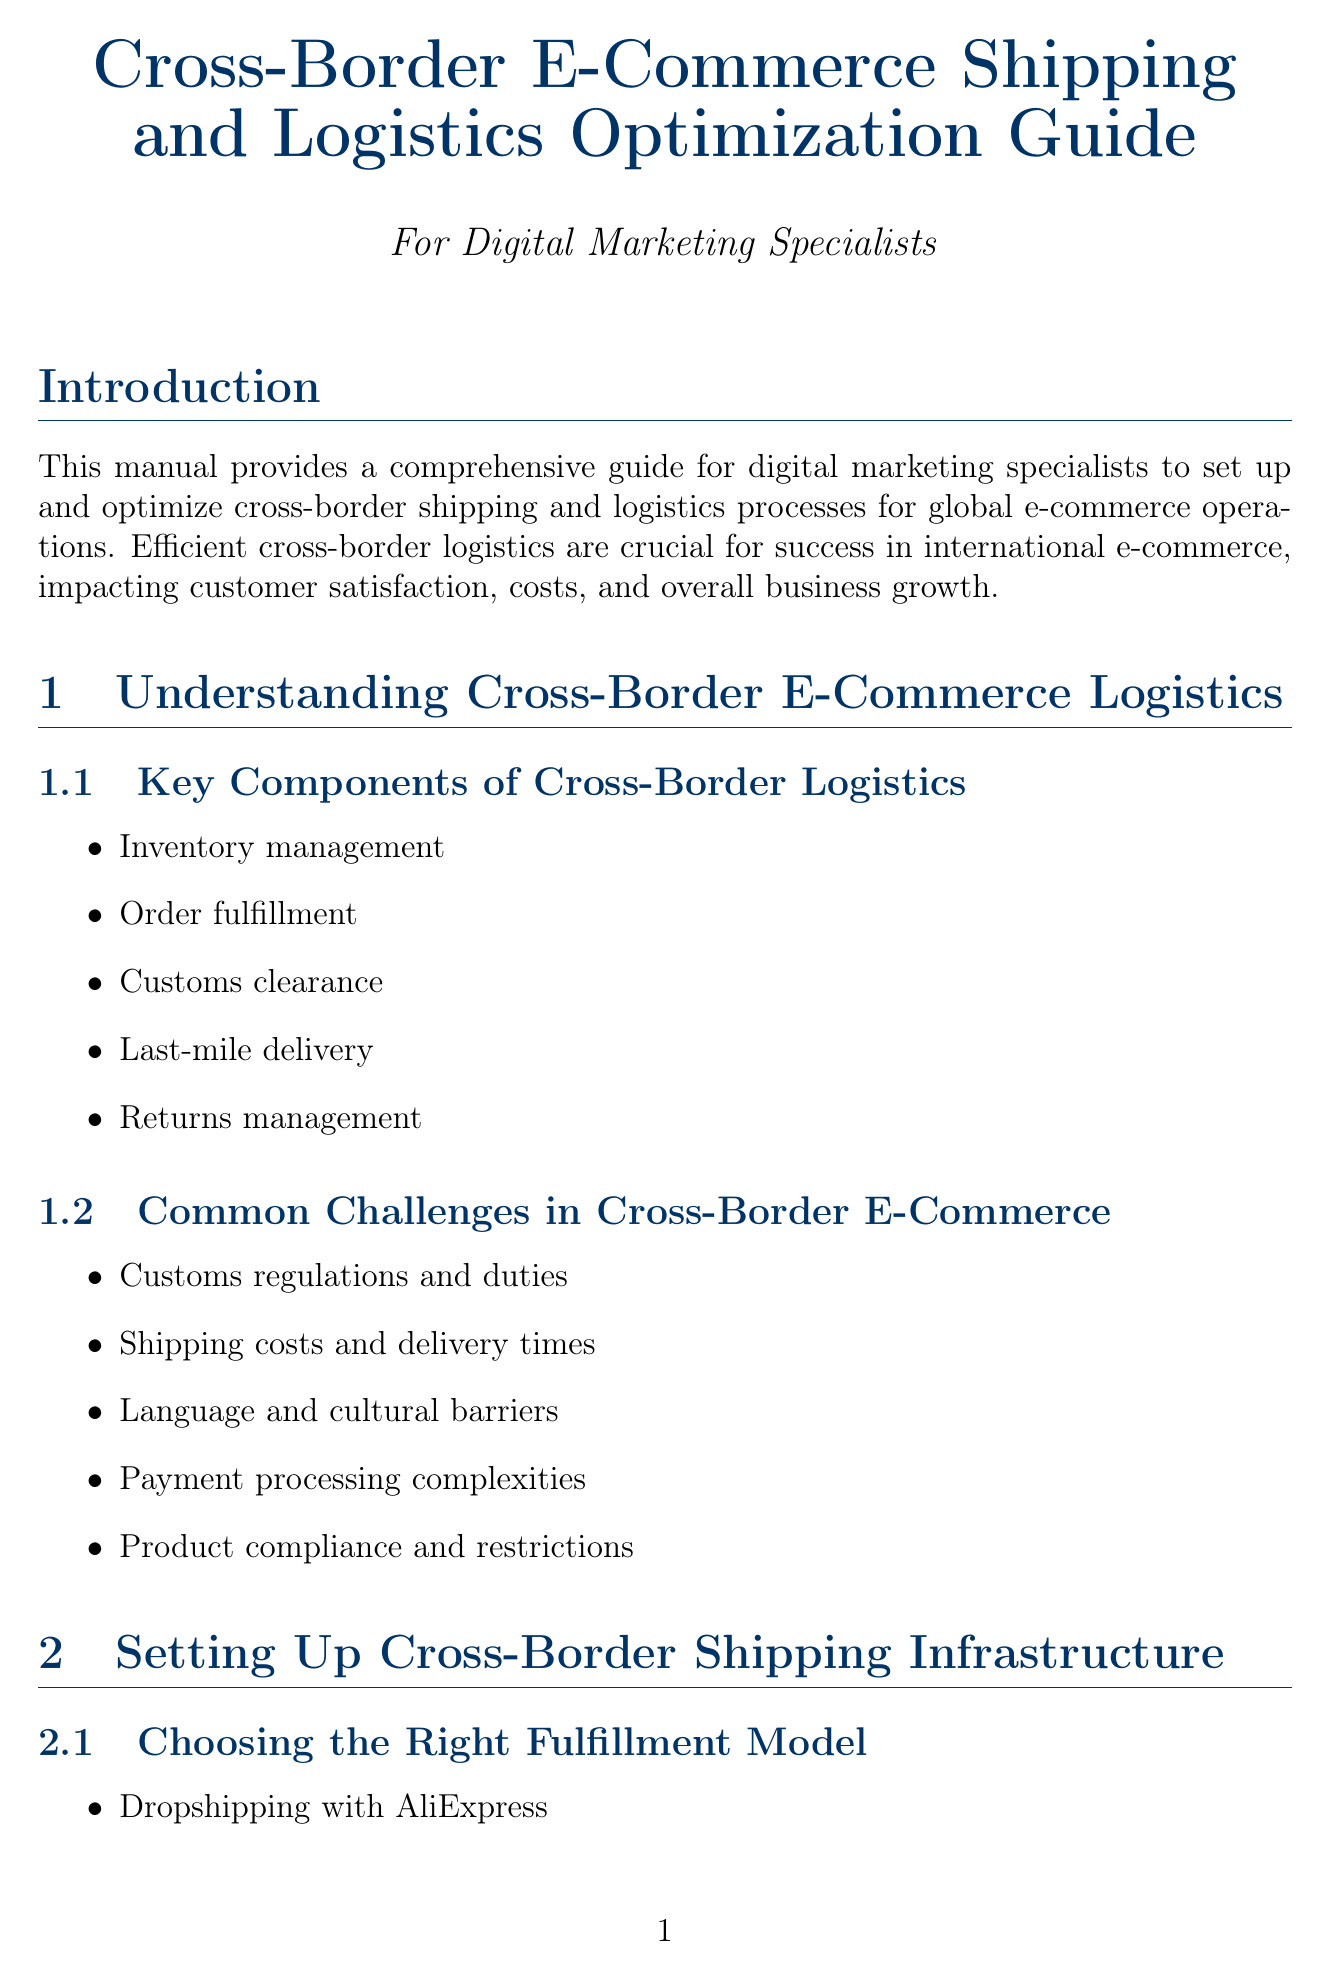what is the title of the manual? The title is specified at the beginning of the document.
Answer: Cross-Border E-Commerce Shipping and Logistics Optimization Guide how many chapters are in the manual? The total number of chapters is listed in the document's structure.
Answer: 6 what is one key component of cross-border logistics? The document lists several components in the relevant section.
Answer: Order fulfillment which fulfillment model is associated with AliExpress? The specific fulfillment model related to AliExpress is mentioned in the document.
Answer: Dropshipping what is one of the common challenges in cross-border e-commerce? The document outlines various challenges in a specific section.
Answer: Customs regulations and duties which platform is mentioned for streamlined international selling? The document provides examples of platforms in the relevant section.
Answer: Shopify Markets what tool is recommended for demand forecasting? The document mentions specific tools for various functionalities.
Answer: IBM Watson what is one key performance indicator for cross-border logistics? The document lists several KPIs under the relevant section.
Answer: On-time delivery rate which technology is discussed for enhancing supply chain transparency? The document outlines technological solutions in a specific section.
Answer: Blockchain 